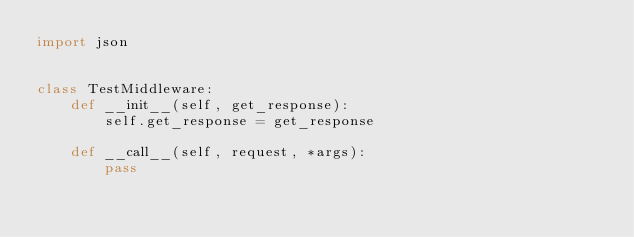Convert code to text. <code><loc_0><loc_0><loc_500><loc_500><_Python_>import json


class TestMiddleware:
    def __init__(self, get_response):
        self.get_response = get_response

    def __call__(self, request, *args):
        pass
</code> 